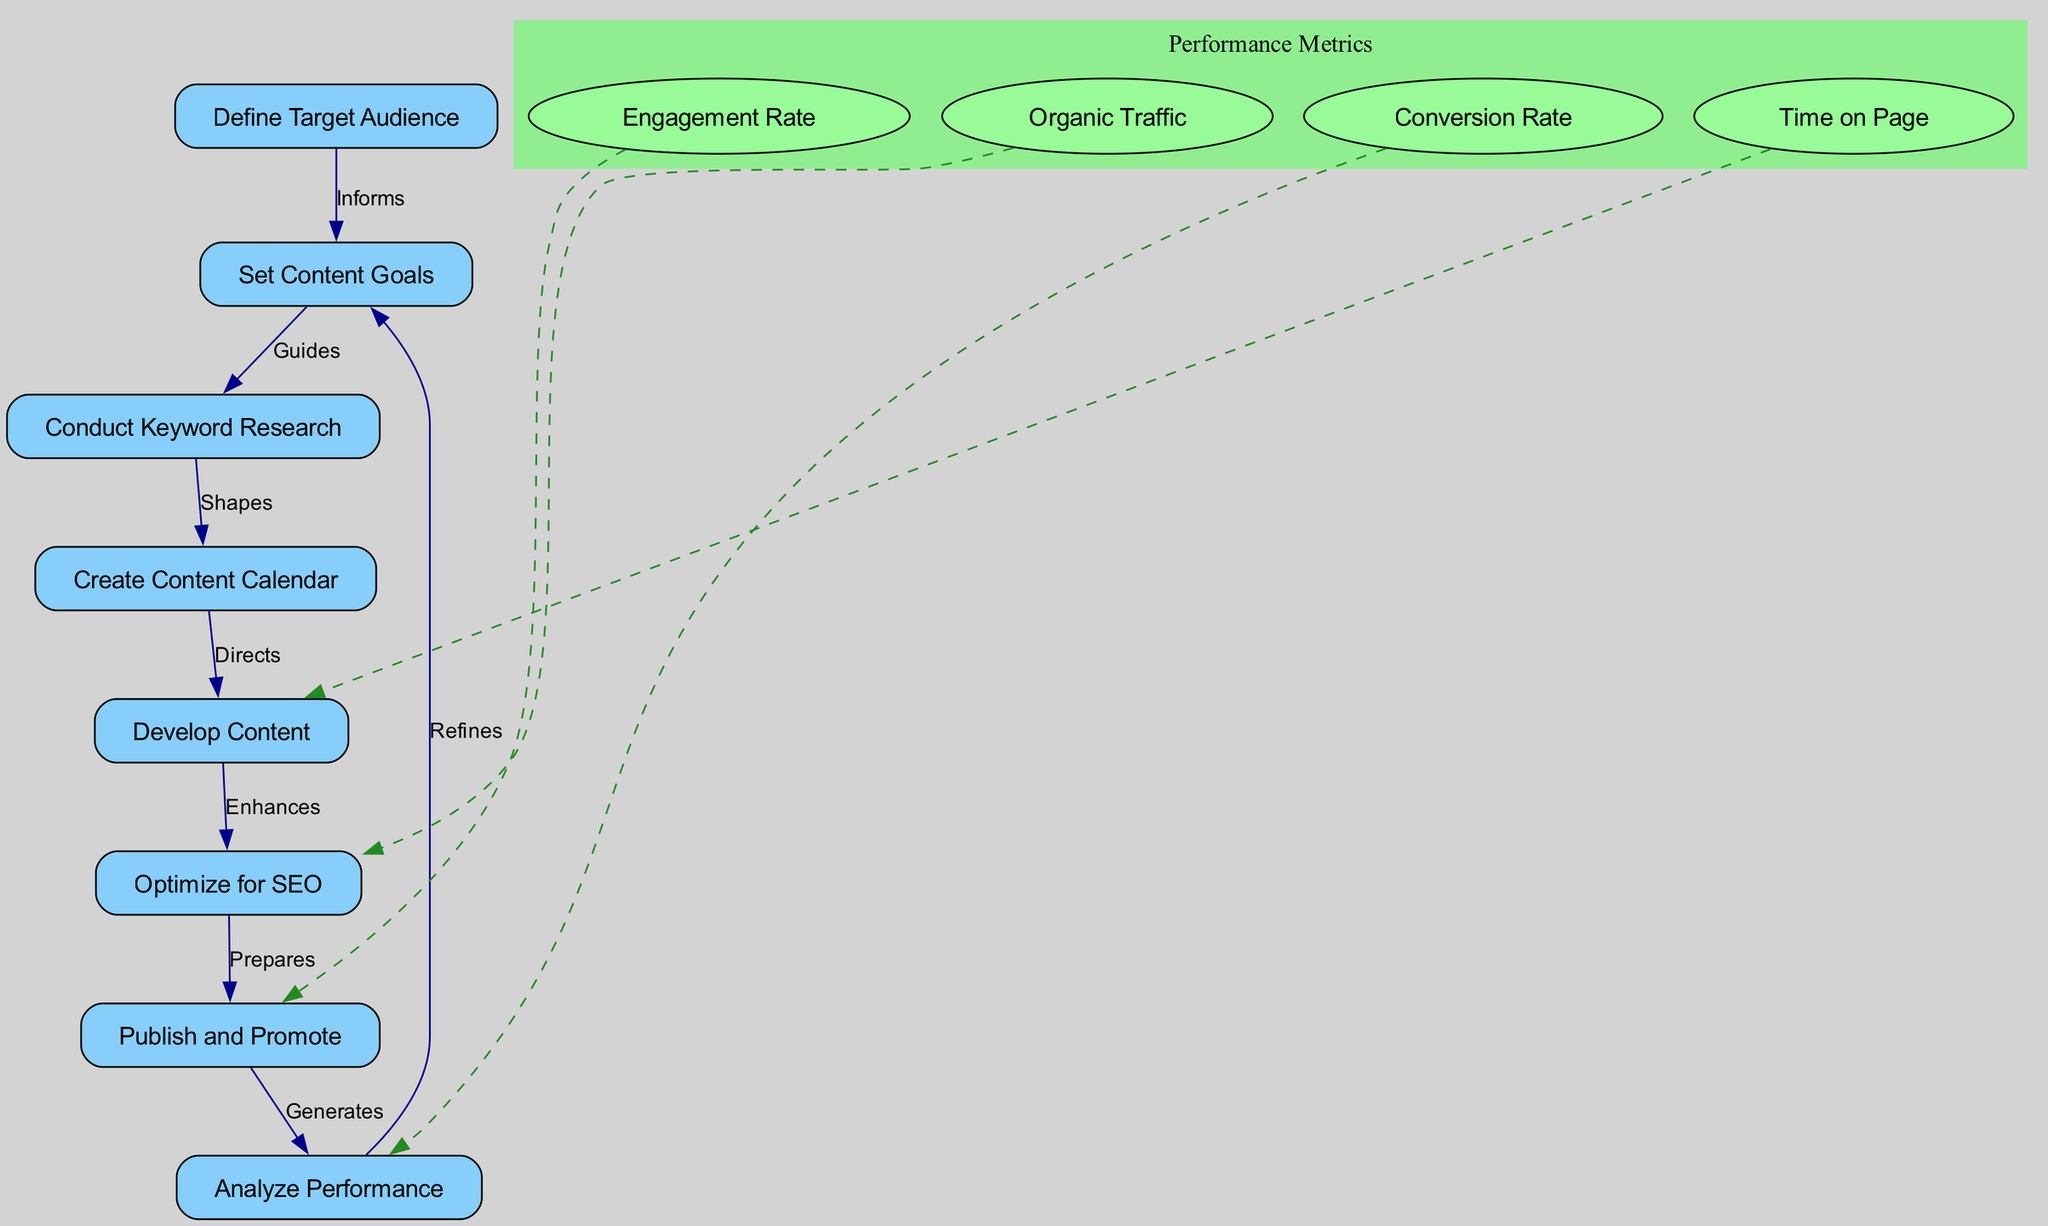What is the first node in the diagram? The diagram starts with the node labeled "Define Target Audience," which is positioned at the top.
Answer: Define Target Audience How many nodes are present in the diagram? The diagram lists a total of eight distinct nodes, each representing a key step in the content strategy.
Answer: Eight What label connects "Set Content Goals" to "Conduct Keyword Research"? The label on the edge connecting "Set Content Goals" to "Conduct Keyword Research" is "Guides."
Answer: Guides Which node is directly linked to "Analyze Performance"? The node that directly follows "Analyze Performance" is "Set Content Goals," as indicated by the edge that connects them.
Answer: Set Content Goals What performance metric is associated with the "Develop Content" node? The metric labeled "Time on Page" is associated with the "Develop Content" node, targeting measurable user engagement on the content created.
Answer: Time on Page What does the connection from "Publish and Promote" lead to? The connection from "Publish and Promote" leads to the "Analyze Performance" node, showing the next step in assessing content effectiveness.
Answer: Analyze Performance Which node does "Conduct Keyword Research" shape? The node shaped by "Conduct Keyword Research" is "Create Content Calendar," guiding the scheduling and planning of content creation.
Answer: Create Content Calendar Which metric is aimed at measuring the effectiveness of SEO optimization? The metric "Organic Traffic" is aimed at assessing the effectiveness of SEO strategies utilized in the content.
Answer: Organic Traffic What does the edge labeled "Generates" indicate? The "Generates" label indicates the relationship where the "Publish and Promote" node produces data or information for performance analysis.
Answer: Generates 